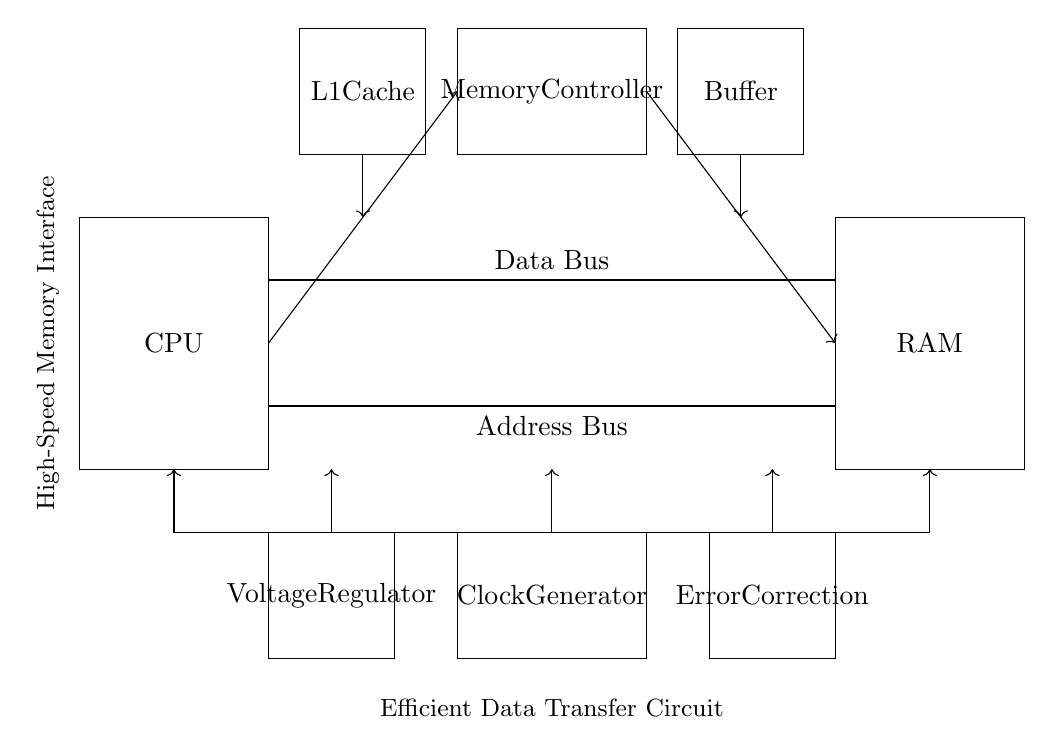What component connects the CPU and RAM? The circuit diagram shows a 'Data Bus' connecting the CPU and RAM. This bus serves as the pathway for data transfer between these components.
Answer: Data Bus What is the function of the Memory Controller? The Memory Controller manages the flow of data between the CPU and RAM, ensuring data is correctly read from and written to memory.
Answer: Manages data flow What type of Cache is present in the circuit? The circuit includes an 'L1 Cache', which is typically the first level of cache memory in a CPU for quick access to frequently used data.
Answer: L1 Cache How many main components are shown in the circuit? The diagram displays six main components: CPU, RAM, Memory Controller, Clock Generator, Buffer, and Voltage Regulator.
Answer: Six What role does the Clock Generator play in this circuit? The Clock Generator provides the necessary timing signals to synchronize the operations of the CPU and the Memory Controller, enabling efficient data transfer.
Answer: Timing signals What is the purpose of the Error Correction component? The Error Correction component checks and corrects any errors that may occur during data transmission between the RAM and CPU, ensuring data integrity.
Answer: Ensures data integrity How is the data transferred from RAM to the CPU in this circuit? Data is transferred from RAM to the CPU through the Data Bus, which facilitates two-way communication as indicated in the diagram.
Answer: Through Data Bus 